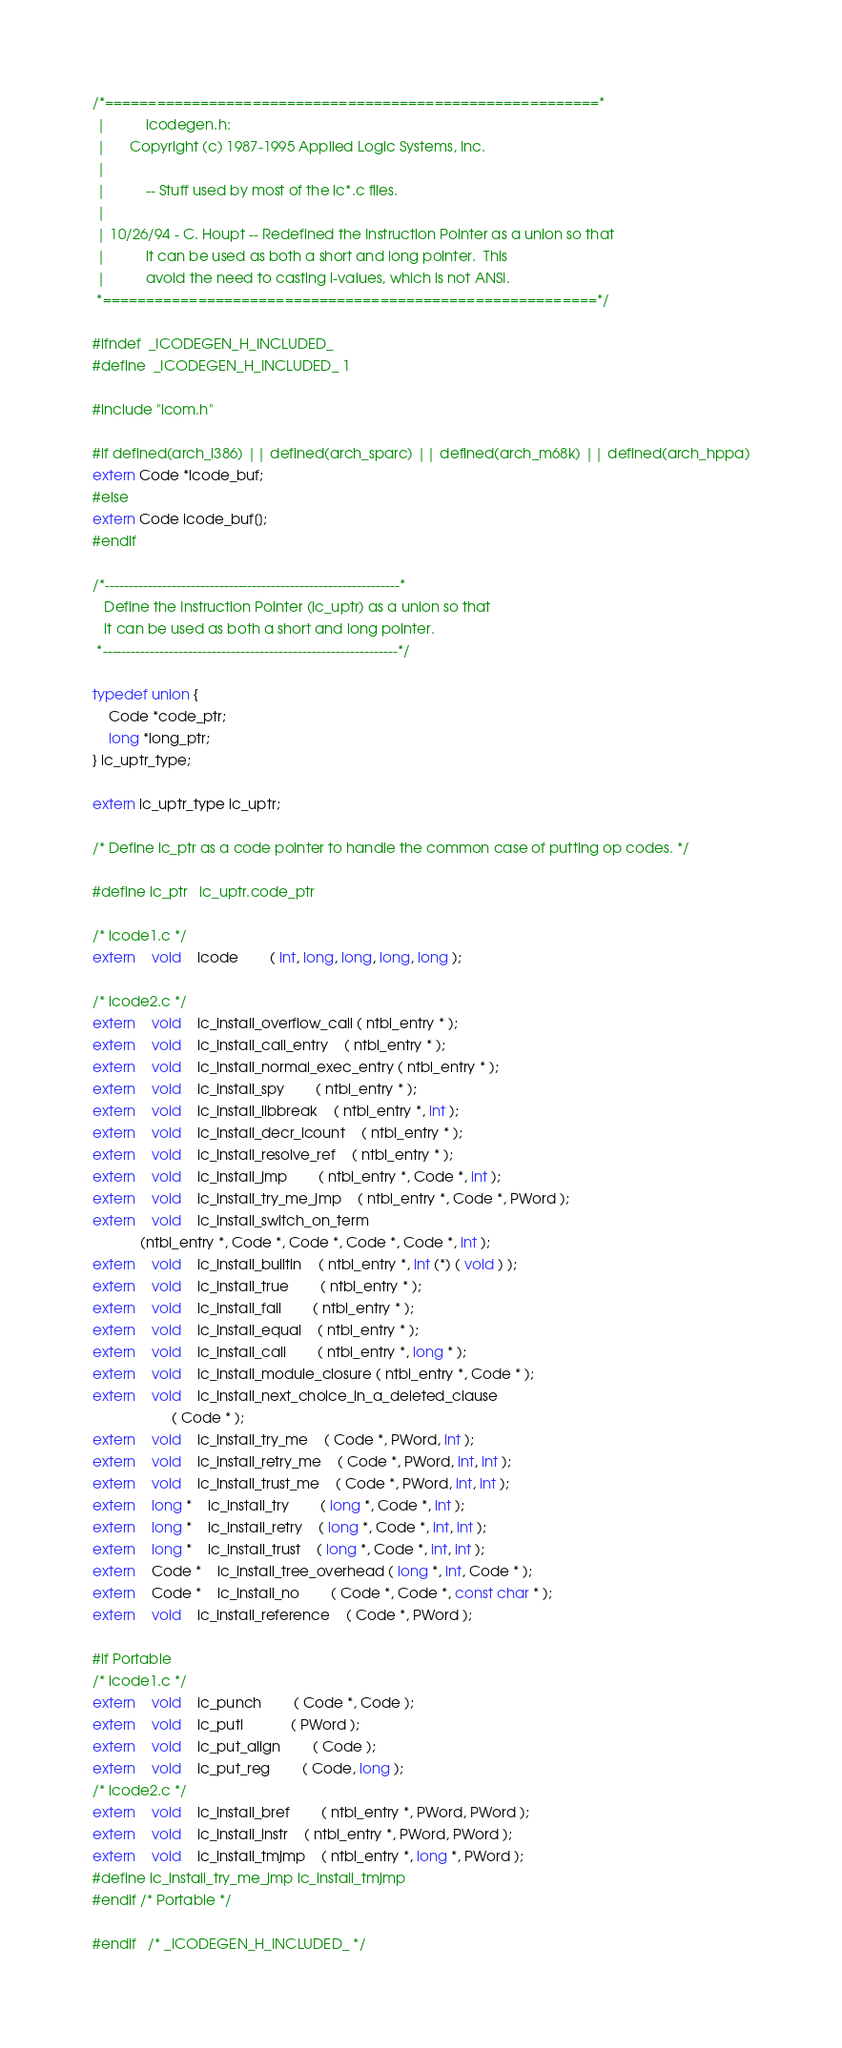<code> <loc_0><loc_0><loc_500><loc_500><_C_>/*=========================================================*
 |			icodegen.h:
 |		Copyright (c) 1987-1995 Applied Logic Systems, Inc.
 |
 |			-- Stuff used by most of the ic*.c files.
 |
 | 10/26/94 - C. Houpt -- Redefined the Instruction Pointer as a union so that
 |	    	it can be used as both a short and long pointer.  This
 |	    	avoid the need to casting l-values, which is not ANSI.
 *=========================================================*/

#ifndef	_ICODEGEN_H_INCLUDED_
#define	_ICODEGEN_H_INCLUDED_ 1

#include "icom.h"

#if defined(arch_i386) || defined(arch_sparc) || defined(arch_m68k) || defined(arch_hppa)
extern Code *icode_buf;
#else 
extern Code icode_buf[];
#endif

/*--------------------------------------------------------------*
   Define the Instruction Pointer (ic_uptr) as a union so that 
   it can be used as both a short and long pointer.
 *--------------------------------------------------------------*/

typedef union {
	Code *code_ptr;
	long *long_ptr;
} ic_uptr_type;

extern ic_uptr_type ic_uptr;

/* Define ic_ptr as a code pointer to handle the common case of putting op codes. */

#define ic_ptr	ic_uptr.code_ptr

/* icode1.c */
extern 	void	icode		( int, long, long, long, long );

/* icode2.c */
extern	void	ic_install_overflow_call ( ntbl_entry * );
extern	void	ic_install_call_entry	( ntbl_entry * );
extern	void	ic_install_normal_exec_entry ( ntbl_entry * );
extern	void	ic_install_spy		( ntbl_entry * );
extern	void	ic_install_libbreak	( ntbl_entry *, int );
extern	void	ic_install_decr_icount	( ntbl_entry * );
extern	void	ic_install_resolve_ref	( ntbl_entry * );
extern	void	ic_install_jmp		( ntbl_entry *, Code *, int );
extern	void	ic_install_try_me_jmp	( ntbl_entry *, Code *, PWord );
extern	void	ic_install_switch_on_term
		    (ntbl_entry *, Code *, Code *, Code *, Code *, int );
extern	void	ic_install_builtin	( ntbl_entry *, int (*) ( void ) );
extern	void	ic_install_true		( ntbl_entry * );
extern	void	ic_install_fail		( ntbl_entry * );
extern	void	ic_install_equal	( ntbl_entry * );
extern	void	ic_install_call		( ntbl_entry *, long * );
extern	void	ic_install_module_closure ( ntbl_entry *, Code * );
extern	void	ic_install_next_choice_in_a_deleted_clause
					( Code * );
extern	void	ic_install_try_me	( Code *, PWord, int );
extern	void	ic_install_retry_me	( Code *, PWord, int, int );
extern	void	ic_install_trust_me	( Code *, PWord, int, int );
extern	long *	ic_install_try		( long *, Code *, int );
extern	long *	ic_install_retry	( long *, Code *, int, int );
extern	long *	ic_install_trust	( long *, Code *, int, int );
extern	Code *	ic_install_tree_overhead ( long *, int, Code * );
extern	Code *	ic_install_no		( Code *, Code *, const char * );
extern	void	ic_install_reference	( Code *, PWord );

#if Portable
/* icode1.c */
extern	void	ic_punch		( Code *, Code );
extern	void	ic_putl			( PWord );
extern	void	ic_put_align		( Code );
extern	void	ic_put_reg		( Code, long );
/* icode2.c */
extern	void	ic_install_bref		( ntbl_entry *, PWord, PWord );
extern	void	ic_install_instr	( ntbl_entry *, PWord, PWord );
extern	void	ic_install_tmjmp	( ntbl_entry *, long *, PWord );
#define ic_install_try_me_jmp ic_install_tmjmp
#endif /* Portable */

#endif	/* _ICODEGEN_H_INCLUDED_ */
</code> 